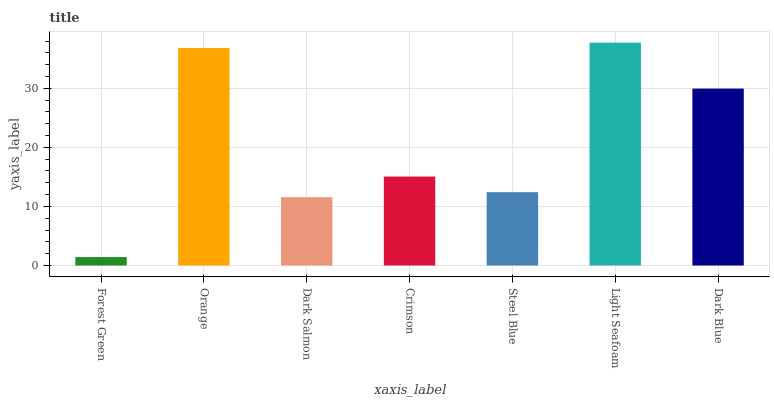Is Forest Green the minimum?
Answer yes or no. Yes. Is Light Seafoam the maximum?
Answer yes or no. Yes. Is Orange the minimum?
Answer yes or no. No. Is Orange the maximum?
Answer yes or no. No. Is Orange greater than Forest Green?
Answer yes or no. Yes. Is Forest Green less than Orange?
Answer yes or no. Yes. Is Forest Green greater than Orange?
Answer yes or no. No. Is Orange less than Forest Green?
Answer yes or no. No. Is Crimson the high median?
Answer yes or no. Yes. Is Crimson the low median?
Answer yes or no. Yes. Is Dark Blue the high median?
Answer yes or no. No. Is Forest Green the low median?
Answer yes or no. No. 